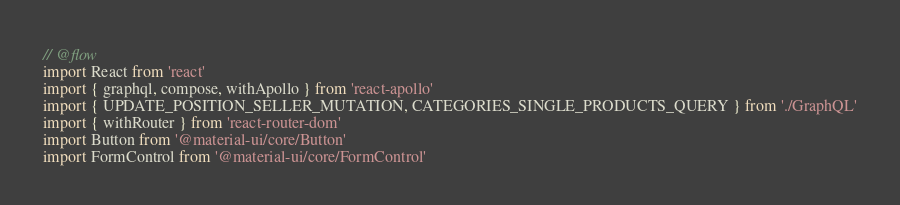Convert code to text. <code><loc_0><loc_0><loc_500><loc_500><_JavaScript_>// @flow
import React from 'react'
import { graphql, compose, withApollo } from 'react-apollo'
import { UPDATE_POSITION_SELLER_MUTATION, CATEGORIES_SINGLE_PRODUCTS_QUERY } from './GraphQL'
import { withRouter } from 'react-router-dom'
import Button from '@material-ui/core/Button'
import FormControl from '@material-ui/core/FormControl'</code> 